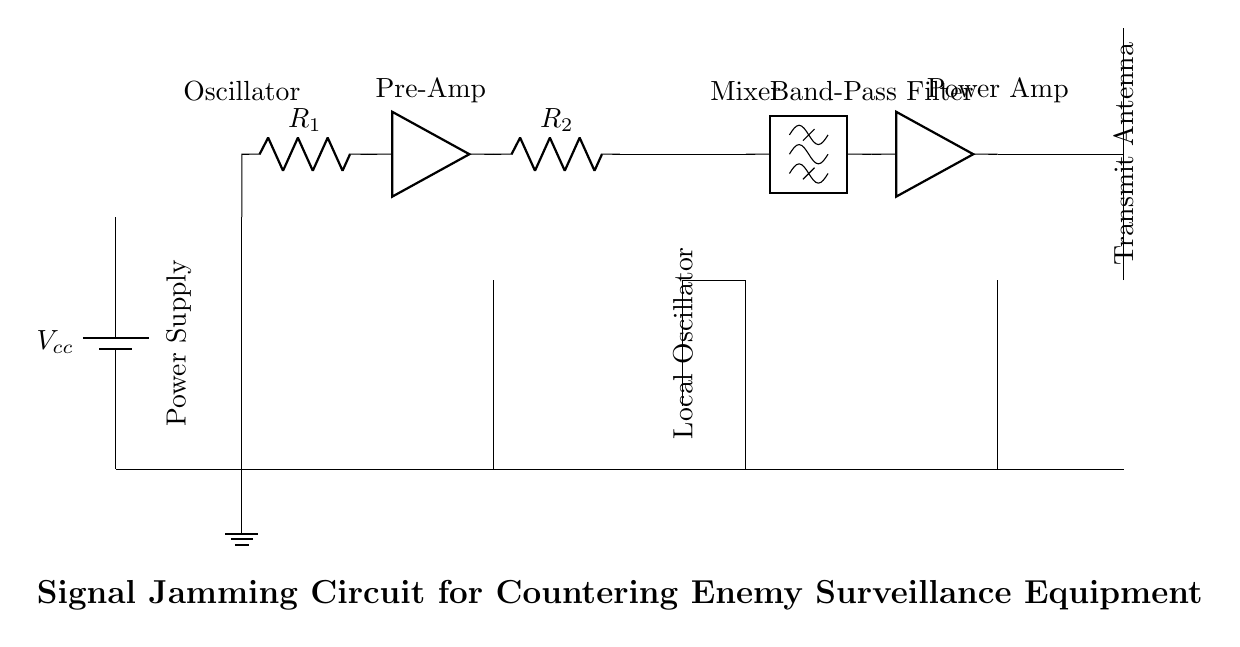What is the power supply voltage in this circuit? The voltage is labeled as Vcc, which refers to the supply voltage used in the circuit. In this case, it’s represented without a specific numerical value, implying it is variable as per design choices.
Answer: Vcc What type of filter is used in this circuit? The component labeled between the mixer and power amplifier is a band-pass filter, which is designed to allow a specific range of frequencies to pass while attenuating those outside that range.
Answer: Band-pass filter How many amplifiers are present in this circuit? There are two amplifiers labeled as Pre-Amp and Power Amp, suggesting their respective stages in signal processing. Counting these components provides the total number of amplifiers in the circuit.
Answer: Two What is the function of the mixer in this circuit? The mixer combines signals from the oscillator and the local oscillator to produce new frequency components used for jamming, making it essential for combining and processing the input signals.
Answer: Combining signals What is the role of the oscillator in this design? The oscillator generates the carrier and modulating signals needed for the jamming process. Its placement at the input signifies its function as a signal source for modulation.
Answer: Generates signals What component connects to the transmit antenna? The power amplifier directly outputs to the transmit antenna, increasing the signal power before transmission to effectively jam the enemy systems.
Answer: Power amplifier 